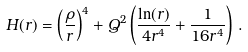<formula> <loc_0><loc_0><loc_500><loc_500>H ( r ) = \left ( \frac { \rho } { r } \right ) ^ { 4 } + Q ^ { 2 } \left ( \frac { \ln ( r ) } { 4 r ^ { 4 } } + \frac { 1 } { 1 6 r ^ { 4 } } \right ) \, .</formula> 